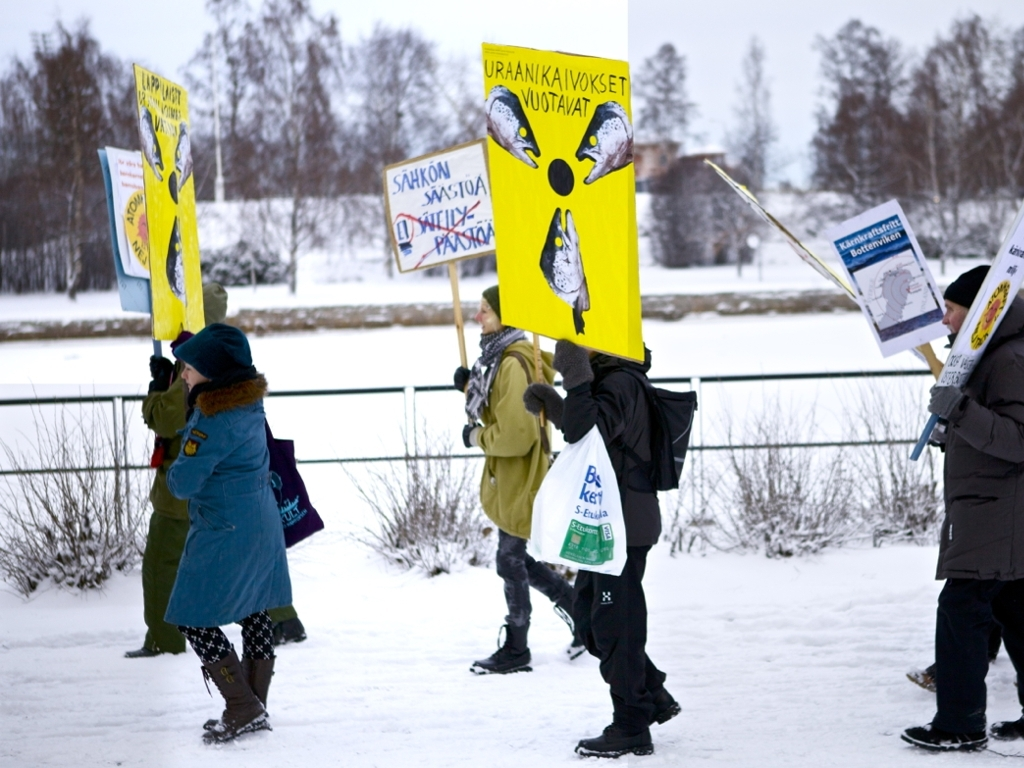Can you infer the possible location of this event based on the visual cues? The presence of snow and the clothing suggest a cold climate, possibly during the winter months in a Northern or cold region. The design of the signs, showing textual content and illustrations, appears to be non-English, which can hint at a location outside of Anglophone countries. Further analysis of the language on the signs, if clear and readable, might provide more specific geographic clues. 